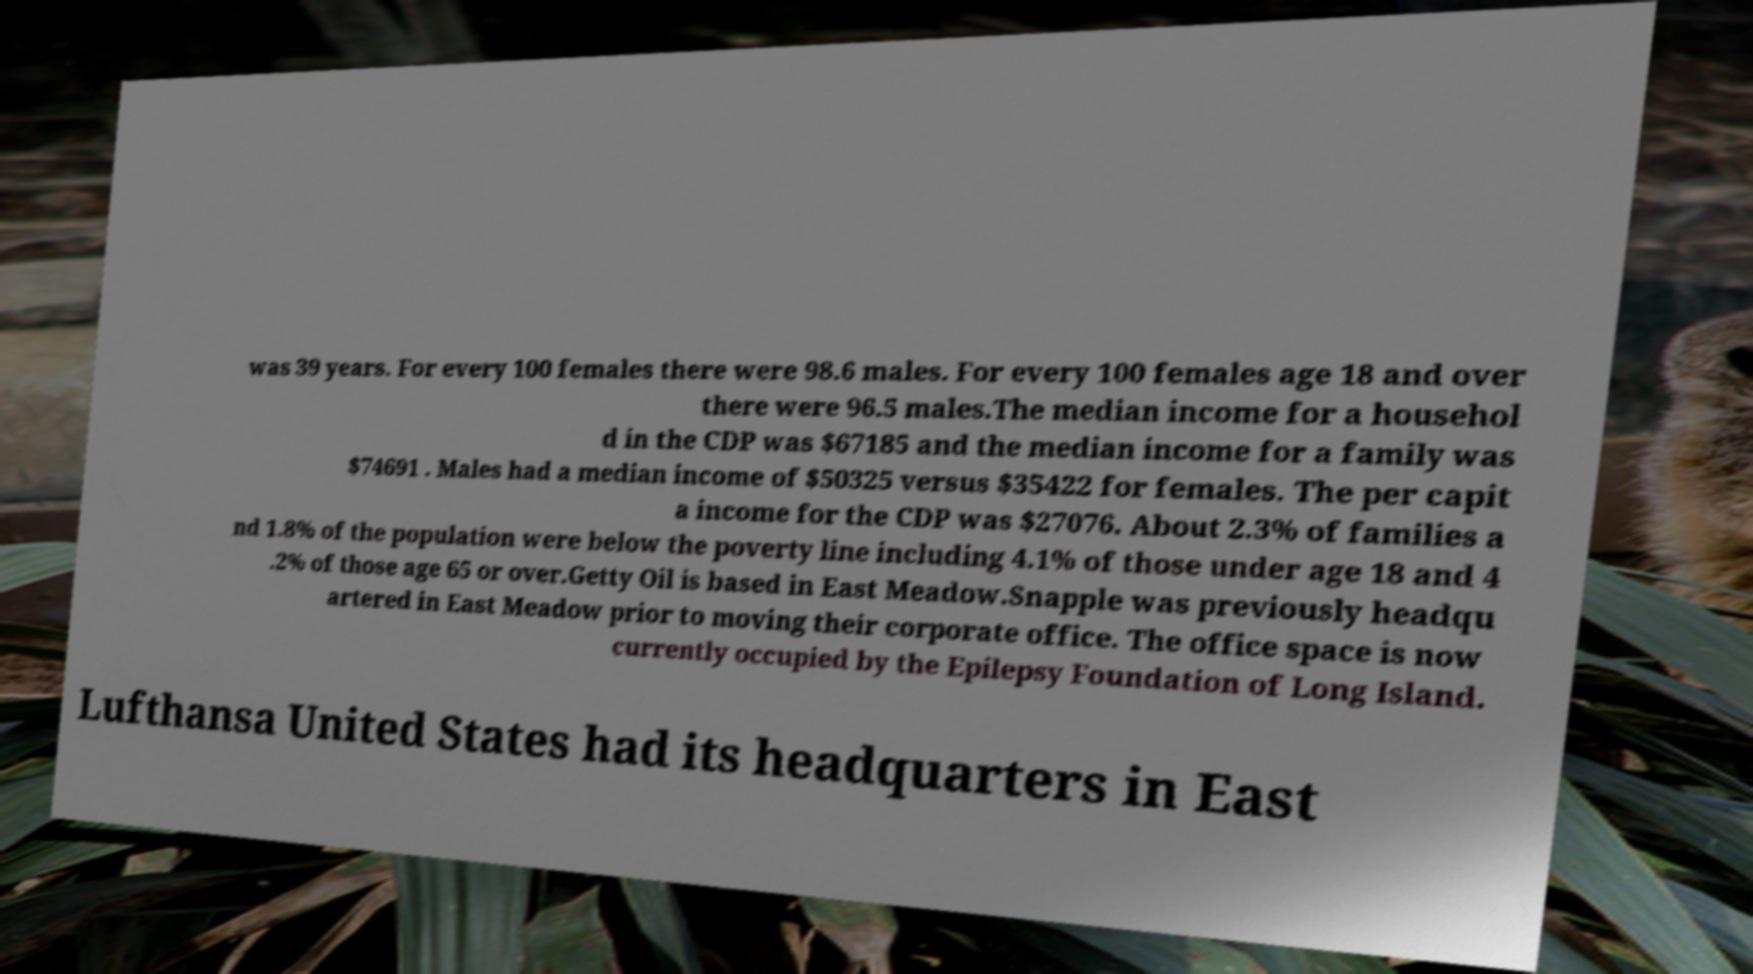What messages or text are displayed in this image? I need them in a readable, typed format. was 39 years. For every 100 females there were 98.6 males. For every 100 females age 18 and over there were 96.5 males.The median income for a househol d in the CDP was $67185 and the median income for a family was $74691 . Males had a median income of $50325 versus $35422 for females. The per capit a income for the CDP was $27076. About 2.3% of families a nd 1.8% of the population were below the poverty line including 4.1% of those under age 18 and 4 .2% of those age 65 or over.Getty Oil is based in East Meadow.Snapple was previously headqu artered in East Meadow prior to moving their corporate office. The office space is now currently occupied by the Epilepsy Foundation of Long Island. Lufthansa United States had its headquarters in East 